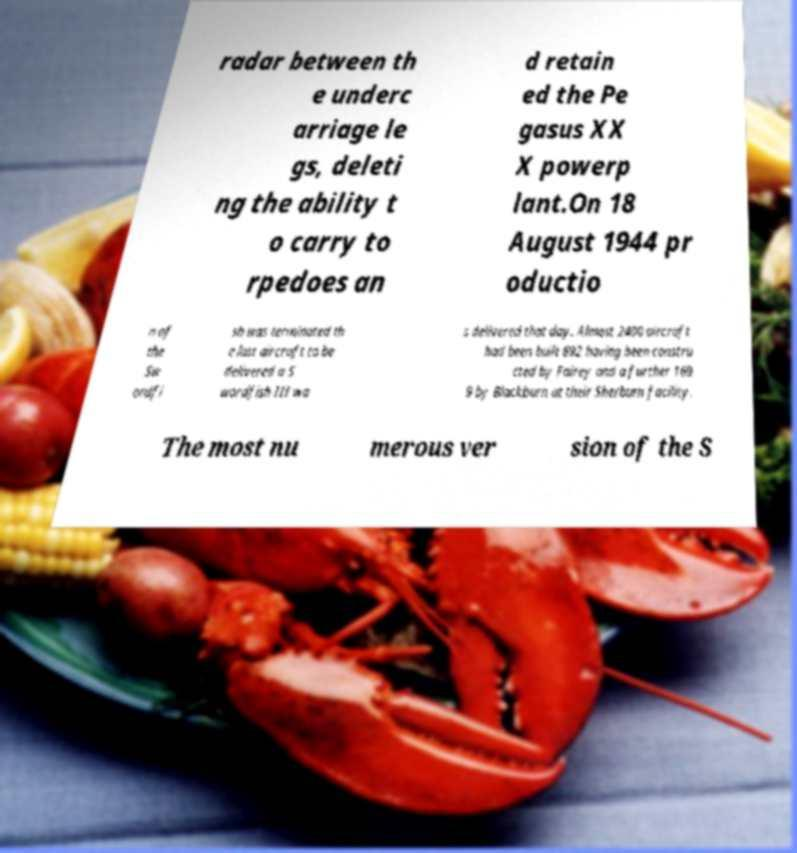Could you assist in decoding the text presented in this image and type it out clearly? radar between th e underc arriage le gs, deleti ng the ability t o carry to rpedoes an d retain ed the Pe gasus XX X powerp lant.On 18 August 1944 pr oductio n of the Sw ordfi sh was terminated th e last aircraft to be delivered a S wordfish III wa s delivered that day. Almost 2400 aircraft had been built 692 having been constru cted by Fairey and a further 169 9 by Blackburn at their Sherburn facility. The most nu merous ver sion of the S 